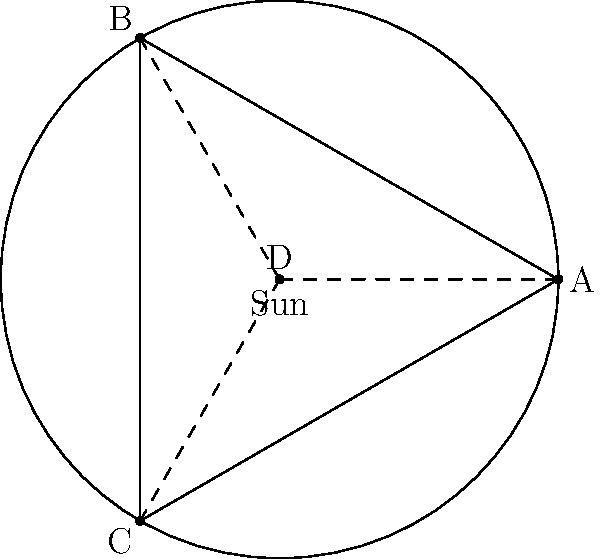In this celestial alignment puzzle, points A, B, and C represent three stars forming a constellation within the Sun's orbit. Point D is the center of this triangular constellation. If the angle between any two adjacent stars from the Sun's perspective is 120°, what is the ratio of the distance between the Sun and point D to the radius of the orbit? To solve this puzzle, let's follow these steps:

1. Recognize that the triangle ABC is equilateral, as the angle between any two adjacent stars is 120°.

2. Point D is the centroid of the equilateral triangle ABC.

3. In an equilateral triangle, the centroid divides each median in the ratio 2:1, with the longer segment closer to the vertex.

4. The distance from any vertex to the center of the circle (Sun) is equal to the radius r.

5. Let the distance from the Sun to point D be x.

6. Using the properties of the centroid, we can write:
   $$x = \frac{2}{3}r$$

7. The ratio of the distance between the Sun and point D to the radius of the orbit is:
   $$\frac{x}{r} = \frac{2/3r}{r} = \frac{2}{3}$$

Therefore, the ratio of the distance between the Sun and point D to the radius of the orbit is 2:3 or 2/3.
Answer: 2/3 